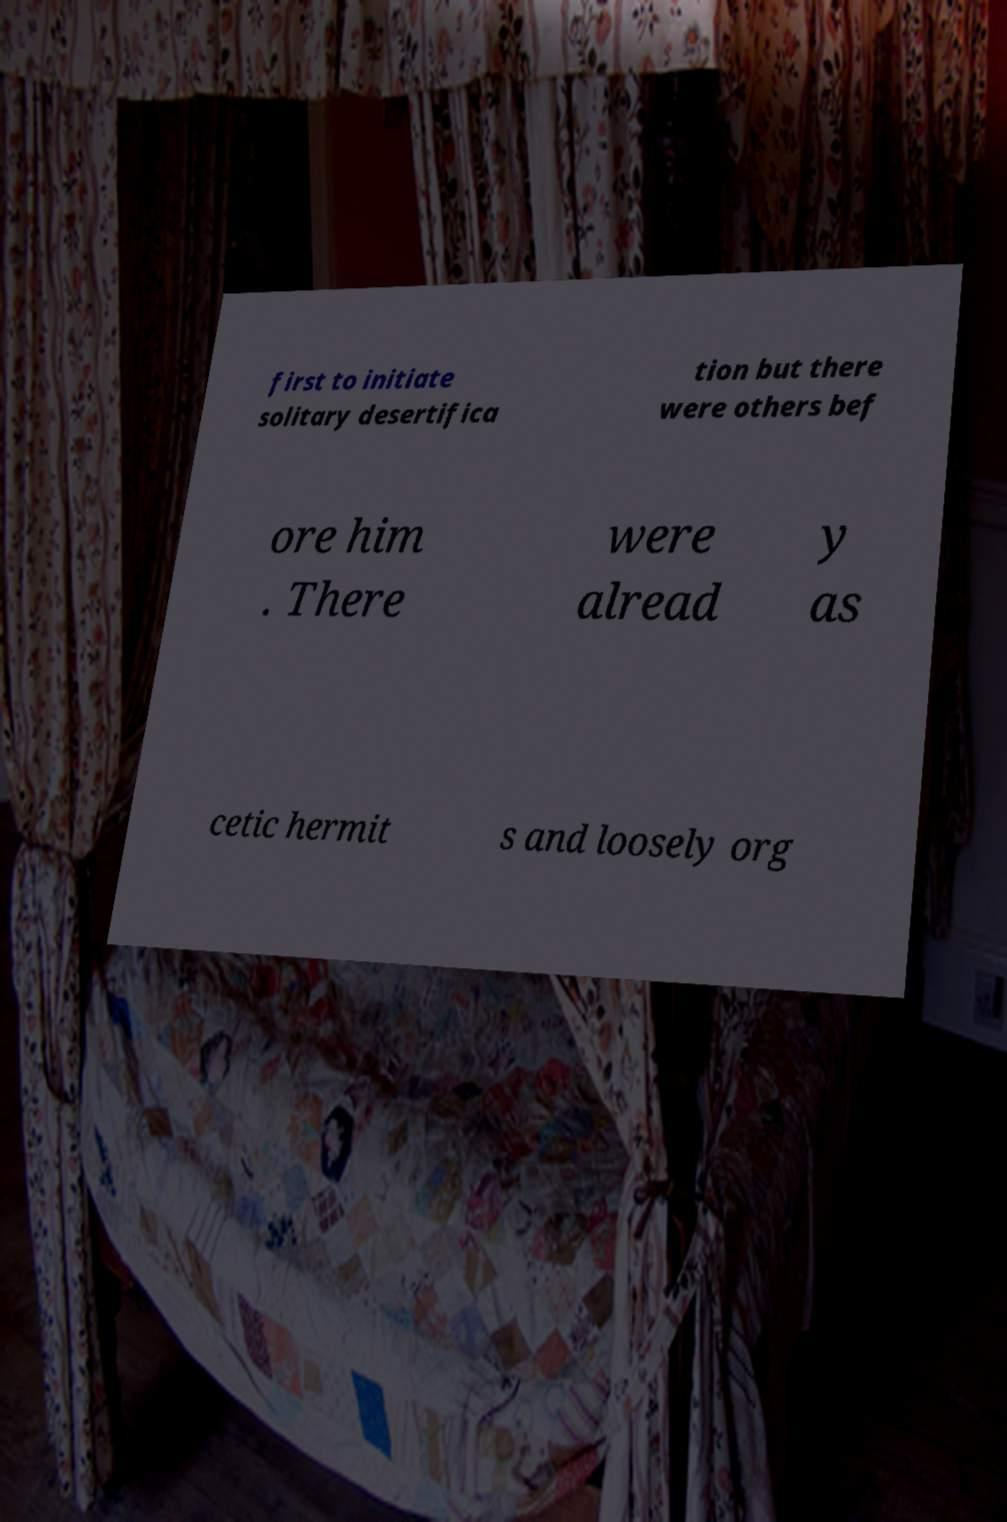Please read and relay the text visible in this image. What does it say? first to initiate solitary desertifica tion but there were others bef ore him . There were alread y as cetic hermit s and loosely org 